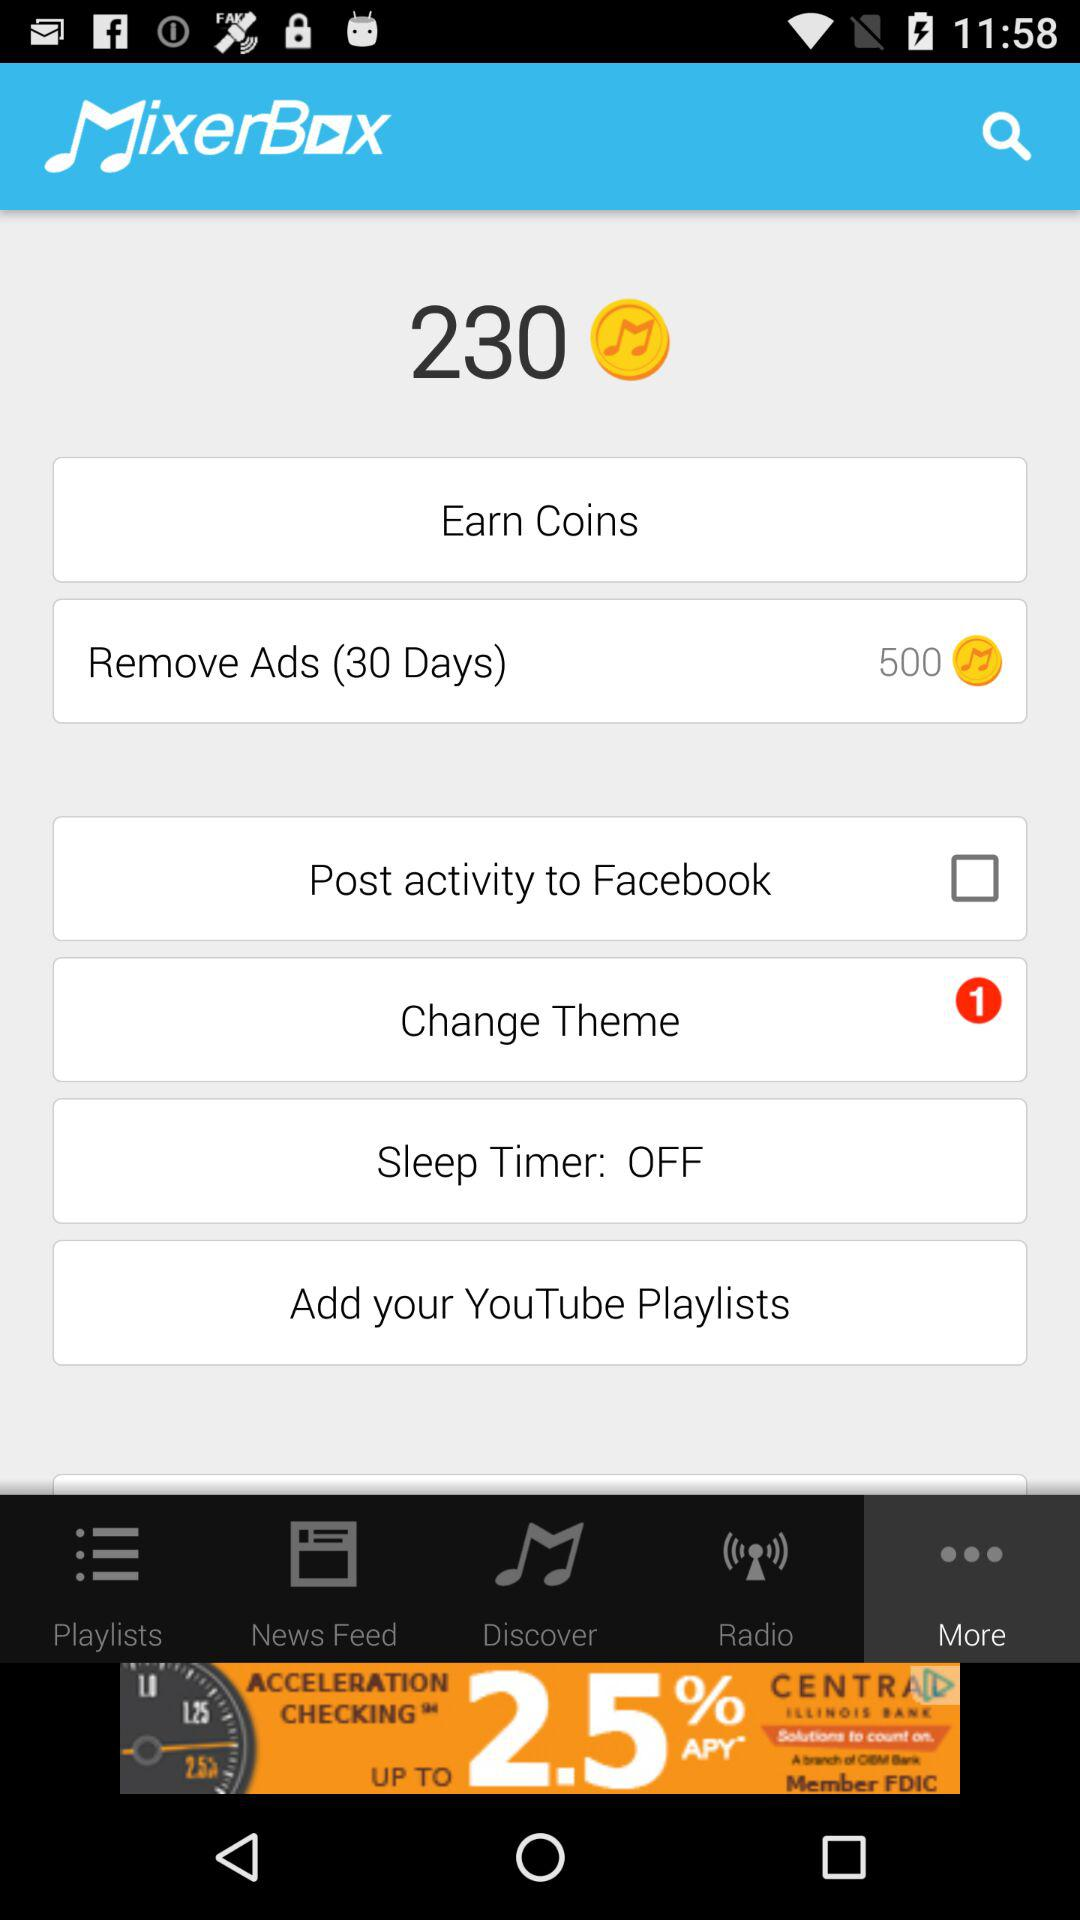What is the given name of the application? The given name of the application is "MixerBox". 